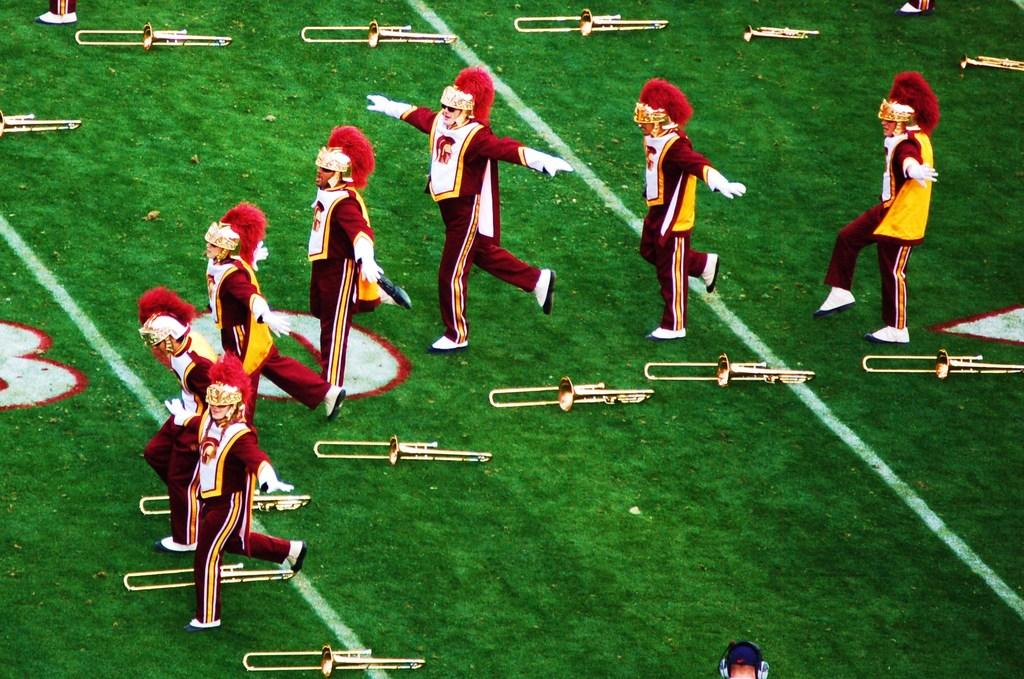How many people are in the image? There is a group of people in the image. What colors are the people wearing? The people are wearing white and maroon color dresses. Where are the people located in the image? The people are on the ground. What objects are near the people on the ground? There are many trumpets on the ground near the people. What type of steel is used to make the teeth of the people in the image? There is no mention of teeth or steel in the image; the people are wearing dresses and there are trumpets on the ground. 